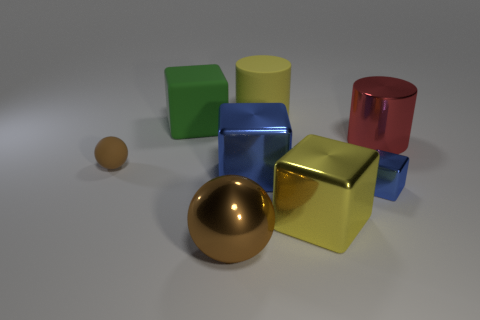What number of things are big gray balls or cubes?
Make the answer very short. 4. How many large red cylinders have the same material as the big blue object?
Ensure brevity in your answer.  1. What is the size of the yellow matte thing that is the same shape as the red metal thing?
Provide a short and direct response. Large. Are there any brown objects in front of the big yellow cube?
Ensure brevity in your answer.  Yes. What is the material of the big green cube?
Keep it short and to the point. Rubber. Does the big shiny cube that is in front of the tiny blue thing have the same color as the rubber cylinder?
Offer a very short reply. Yes. Is there anything else that has the same shape as the large blue metal thing?
Your answer should be compact. Yes. The tiny metallic object that is the same shape as the large yellow metal object is what color?
Keep it short and to the point. Blue. There is a object in front of the big yellow shiny object; what is it made of?
Provide a succinct answer. Metal. The tiny block is what color?
Provide a succinct answer. Blue. 